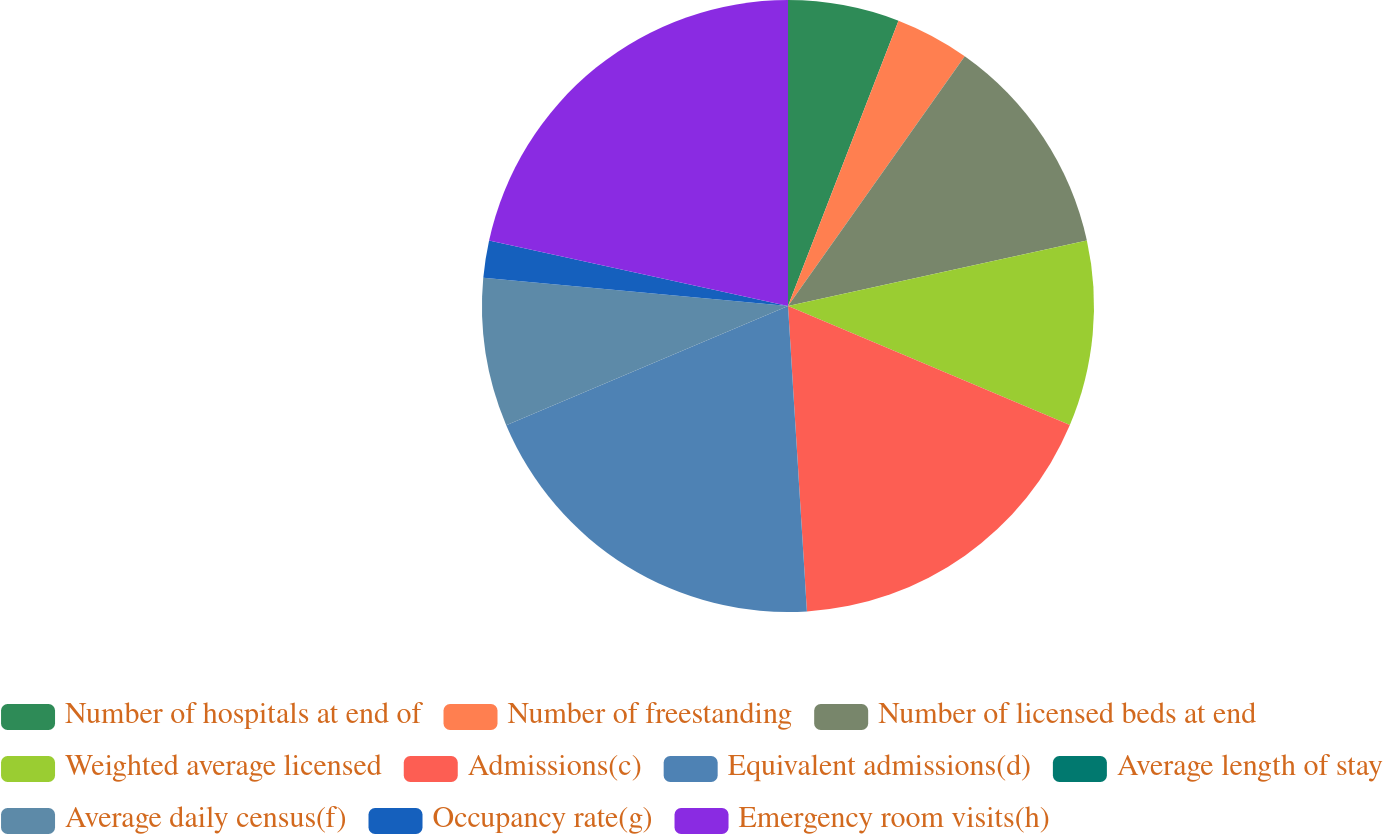<chart> <loc_0><loc_0><loc_500><loc_500><pie_chart><fcel>Number of hospitals at end of<fcel>Number of freestanding<fcel>Number of licensed beds at end<fcel>Weighted average licensed<fcel>Admissions(c)<fcel>Equivalent admissions(d)<fcel>Average length of stay<fcel>Average daily census(f)<fcel>Occupancy rate(g)<fcel>Emergency room visits(h)<nl><fcel>5.88%<fcel>3.92%<fcel>11.76%<fcel>9.8%<fcel>17.65%<fcel>19.61%<fcel>0.0%<fcel>7.84%<fcel>1.96%<fcel>21.57%<nl></chart> 